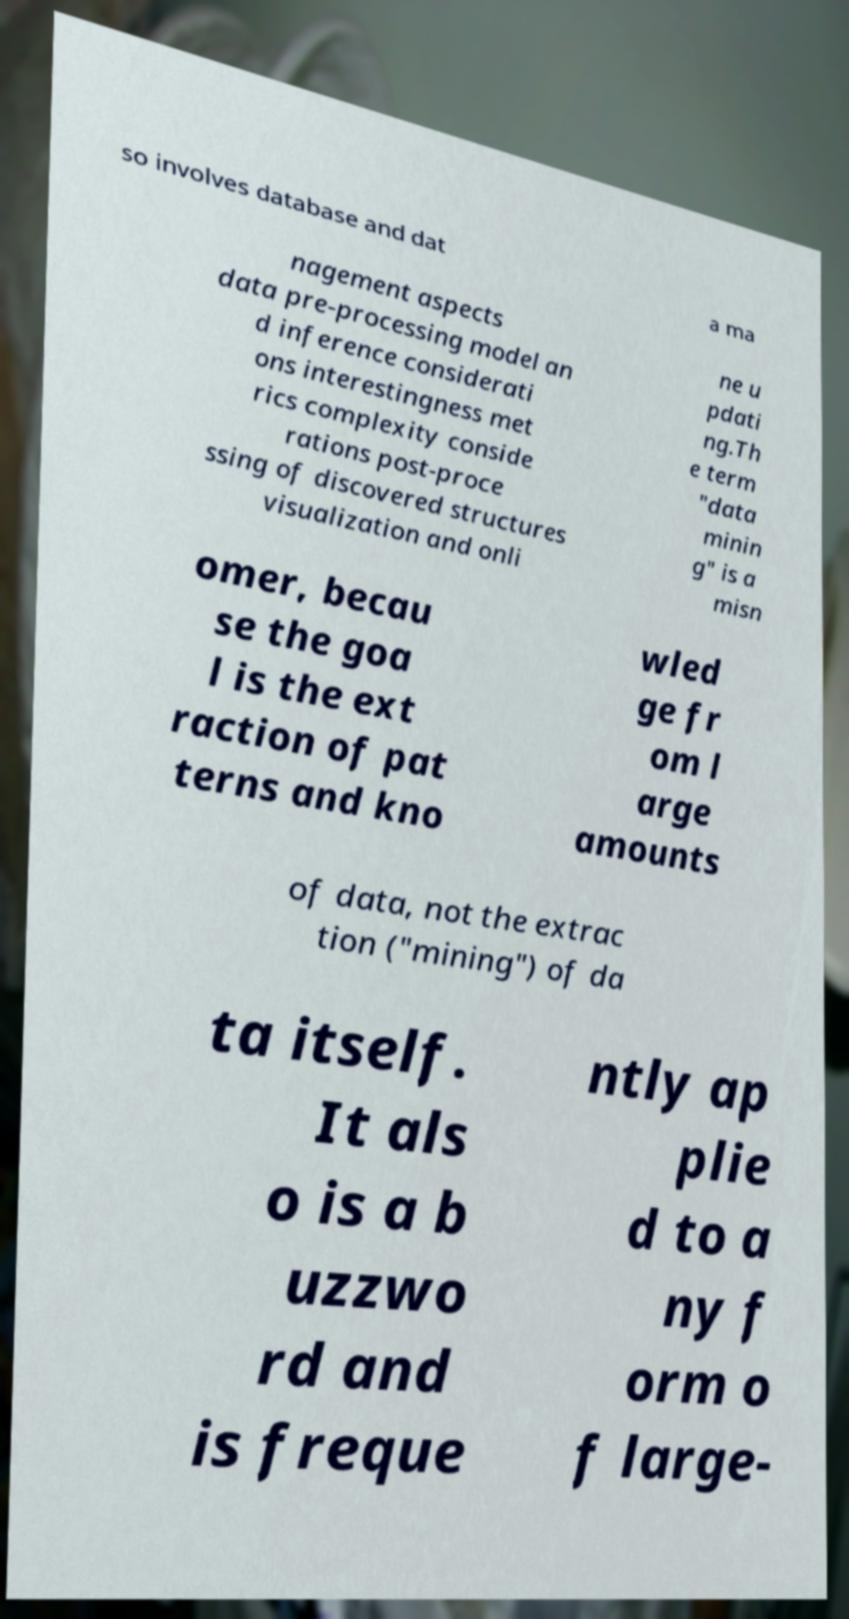For documentation purposes, I need the text within this image transcribed. Could you provide that? so involves database and dat a ma nagement aspects data pre-processing model an d inference considerati ons interestingness met rics complexity conside rations post-proce ssing of discovered structures visualization and onli ne u pdati ng.Th e term "data minin g" is a misn omer, becau se the goa l is the ext raction of pat terns and kno wled ge fr om l arge amounts of data, not the extrac tion ("mining") of da ta itself. It als o is a b uzzwo rd and is freque ntly ap plie d to a ny f orm o f large- 